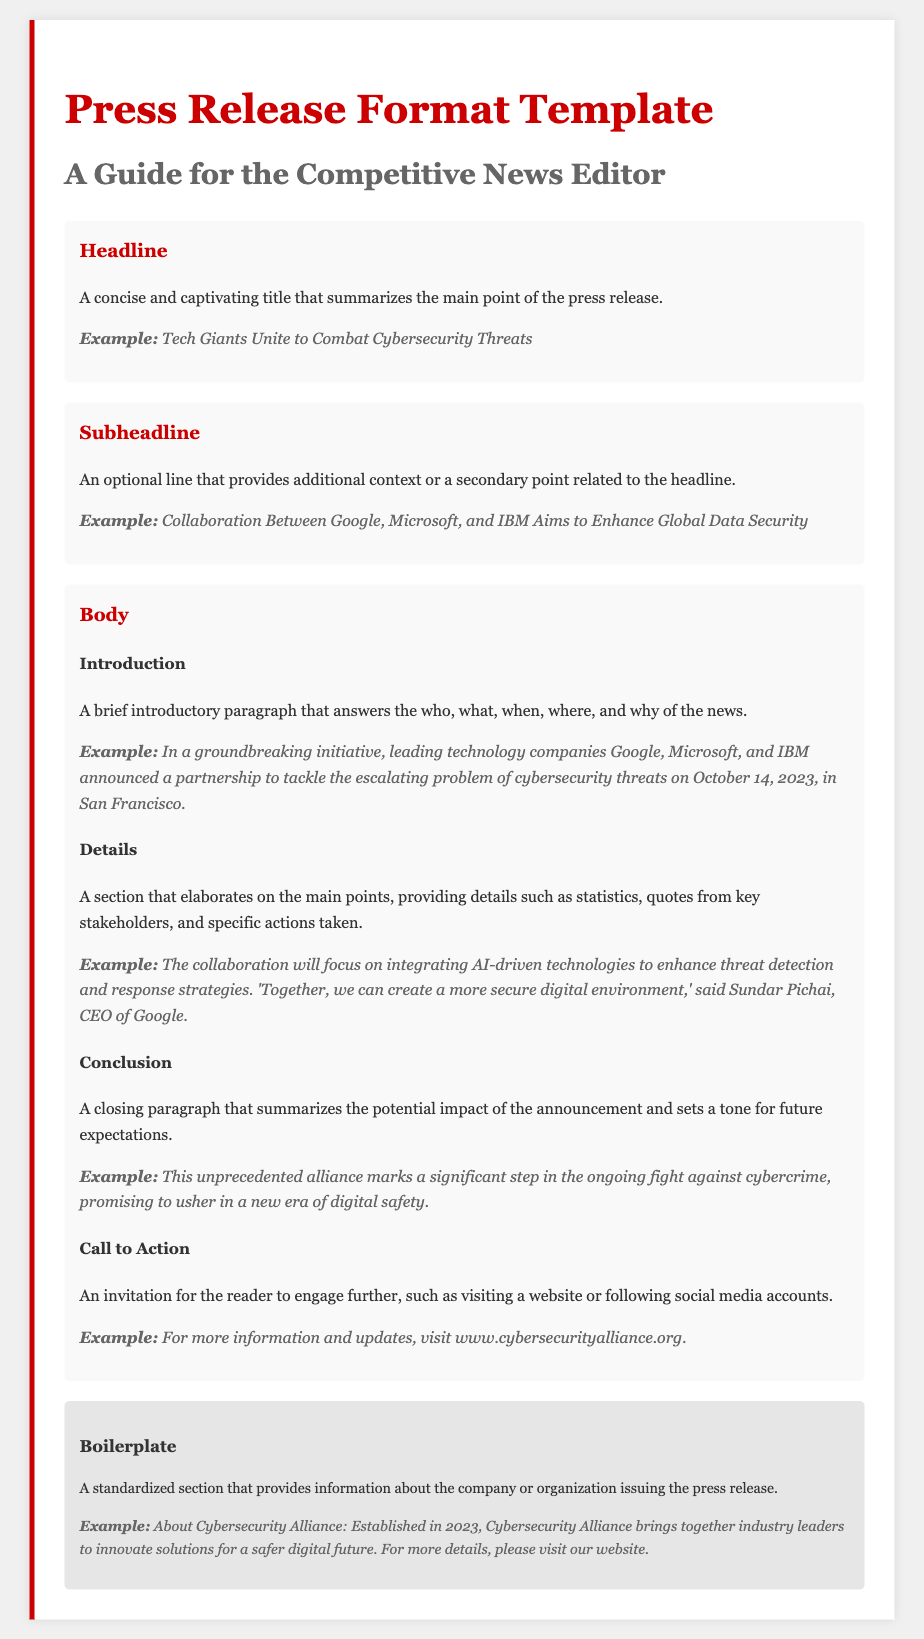What is the main purpose of the headline in a press release? The headline is designed to be a concise and captivating title that summarizes the main point of the press release.
Answer: To summarize the main point What color is used for the headline text? The document specifies that the headline text is in red (#c00).
Answer: Red What date was the partnership announced? The date of the announcement mentioned in the document is October 14, 2023.
Answer: October 14, 2023 Who are the key companies involved in the cybersecurity alliance? The key companies mentioned in the document are Google, Microsoft, and IBM.
Answer: Google, Microsoft, and IBM What section provides a summary about the issuing organization? The standardized section providing information about the organization is called the boilerplate.
Answer: Boilerplate What is the purpose of the call to action in a press release? The call to action serves as an invitation for the reader to engage further, such as visiting a website or following social media accounts.
Answer: To engage the reader What should the introduction of the body answer? The introduction should answer the who, what, when, where, and why of the news.
Answer: Who, what, when, where, and why In which city was the announcement made? The announcement took place in San Francisco, as stated in the document.
Answer: San Francisco What are the two optional elements in the press release format? The optional elements mentioned are the subheadline and additional quotes.
Answer: Subheadline and quotes 